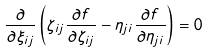<formula> <loc_0><loc_0><loc_500><loc_500>\frac { \partial } { \partial \xi _ { i j } } \left ( \zeta _ { i j } \frac { \partial f } { \partial \zeta _ { i j } } - \eta _ { j i } \frac { \partial f } { \partial \eta _ { j i } } \right ) = 0</formula> 